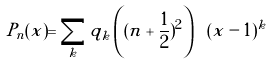<formula> <loc_0><loc_0><loc_500><loc_500>P _ { n } ( x ) = \sum _ { k } q _ { k } \left ( ( n + { \frac { 1 } { 2 } ) ^ { 2 } } \right ) \ ( x - 1 ) ^ { k }</formula> 